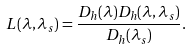<formula> <loc_0><loc_0><loc_500><loc_500>L ( \lambda , \lambda _ { s } ) = \frac { D _ { h } ( \lambda ) D _ { h } ( \lambda , \lambda _ { s } ) } { D _ { h } ( \lambda _ { s } ) } .</formula> 